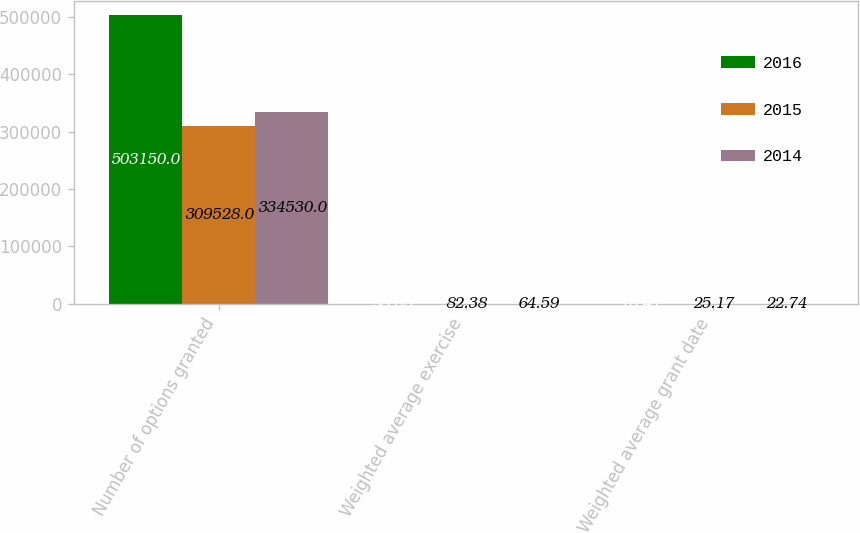<chart> <loc_0><loc_0><loc_500><loc_500><stacked_bar_chart><ecel><fcel>Number of options granted<fcel>Weighted average exercise<fcel>Weighted average grant date<nl><fcel>2016<fcel>503150<fcel>58.83<fcel>16.41<nl><fcel>2015<fcel>309528<fcel>82.38<fcel>25.17<nl><fcel>2014<fcel>334530<fcel>64.59<fcel>22.74<nl></chart> 